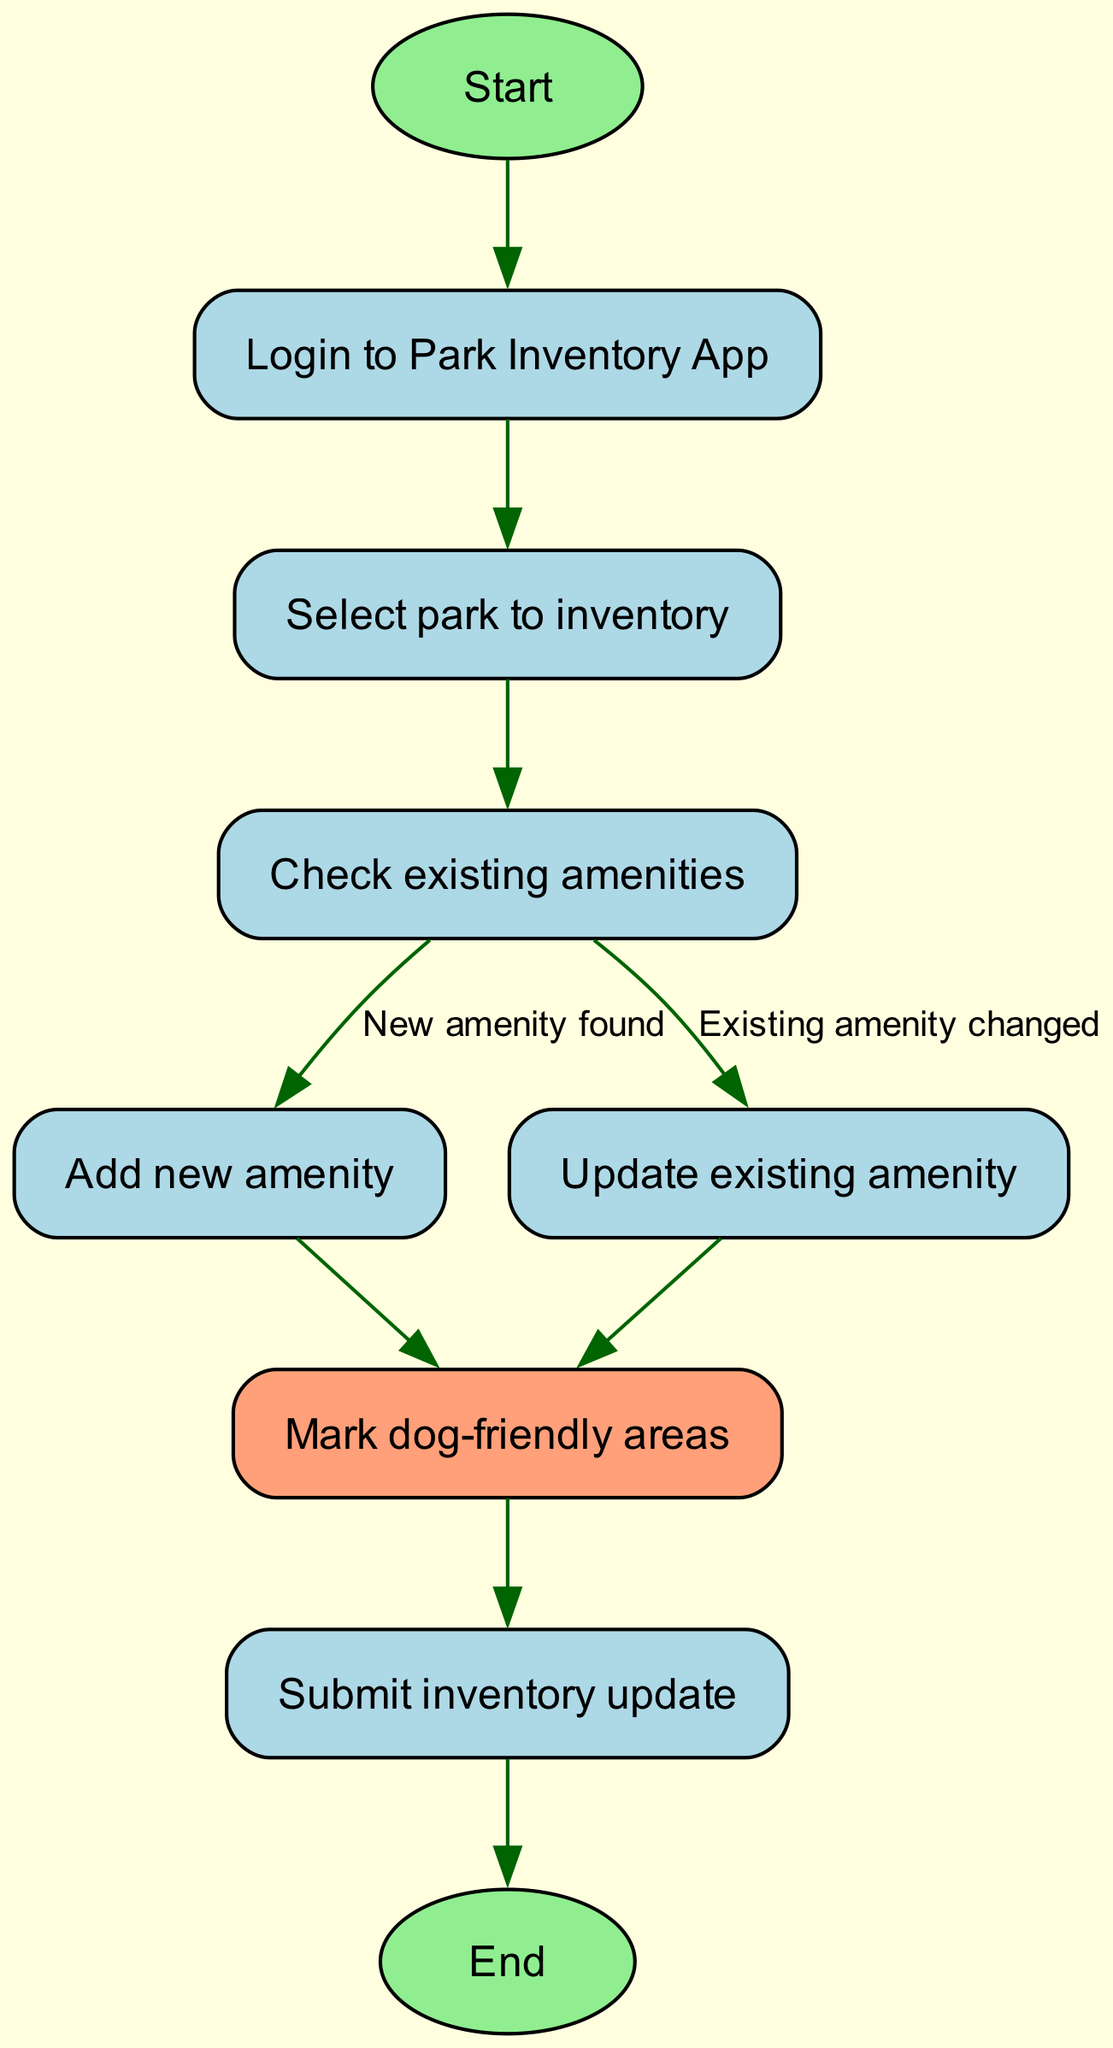What is the first step in the park amenities inventory system? The first step in the process is to start the system, which is indicated by the "Start" node. This node leads directly to the login process.
Answer: Start How many nodes are present in this flowchart? By counting all the unique nodes listed in the data, there are 9 nodes in total. Each represents a step in the inventory system process.
Answer: 9 What step follows after logging into the app? After logging into the app, the next step is to select the park to inventory, as indicated by the edge leading from the "Login to Park Inventory App" node to the "Select park to inventory" node.
Answer: Select park to inventory Which node leads to marking dog-friendly areas? Both the "Add new amenity" and "Update existing amenity" nodes lead to the "Mark dog-friendly areas" node. This means both paths can result in marking areas that are suitable for dogs.
Answer: Mark dog-friendly areas What happens if an existing amenity has changed? If an existing amenity is changed, it leads to the "Update existing amenity" node, which then directs to the "Mark dog-friendly areas" node and ultimately to submitting the inventory update. This flow indicates the process of handling changes to amenities.
Answer: Update existing amenity Which node is a decision point about amenities? The "Check existing amenities" node is the decision point where the flow diverges based on whether new amenities are found or existing ones have changed. This node leads to two different paths: adding a new amenity or updating an existing one.
Answer: Check existing amenities How many edges connect the "Submit inventory update" node to the next action? The "Submit inventory update" node connects to one subsequent action, which is the "End" node, indicating the completion of the inventory update process.
Answer: 1 What is the purpose of the "Login to Park Inventory App" node? The purpose of the "Login to Park Inventory App" node is to initiate user access to the system, allowing the user to proceed to select a park for inventorying amenities after successful login.
Answer: Initiate user access Which amenity-related task occurs directly before submitting an inventory update? The task that occurs directly before submitting an inventory update is marking dog-friendly areas. This is the final step before the inventory update is submitted.
Answer: Mark dog-friendly areas 